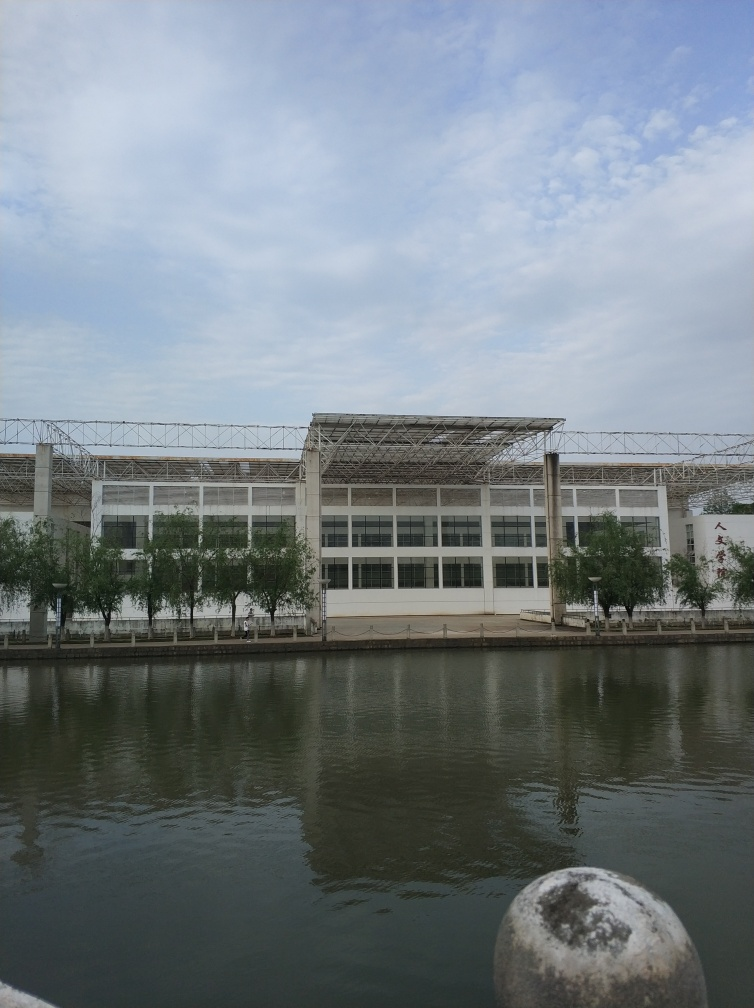What time of day does the lighting in the image suggest? The lighting in the image suggests it is either morning or late afternoon, as evidenced by the soft, diffused light and the lack of strong shadows. The sky is overcast, which scatters the light evenly and suggests a tranquil atmosphere. 